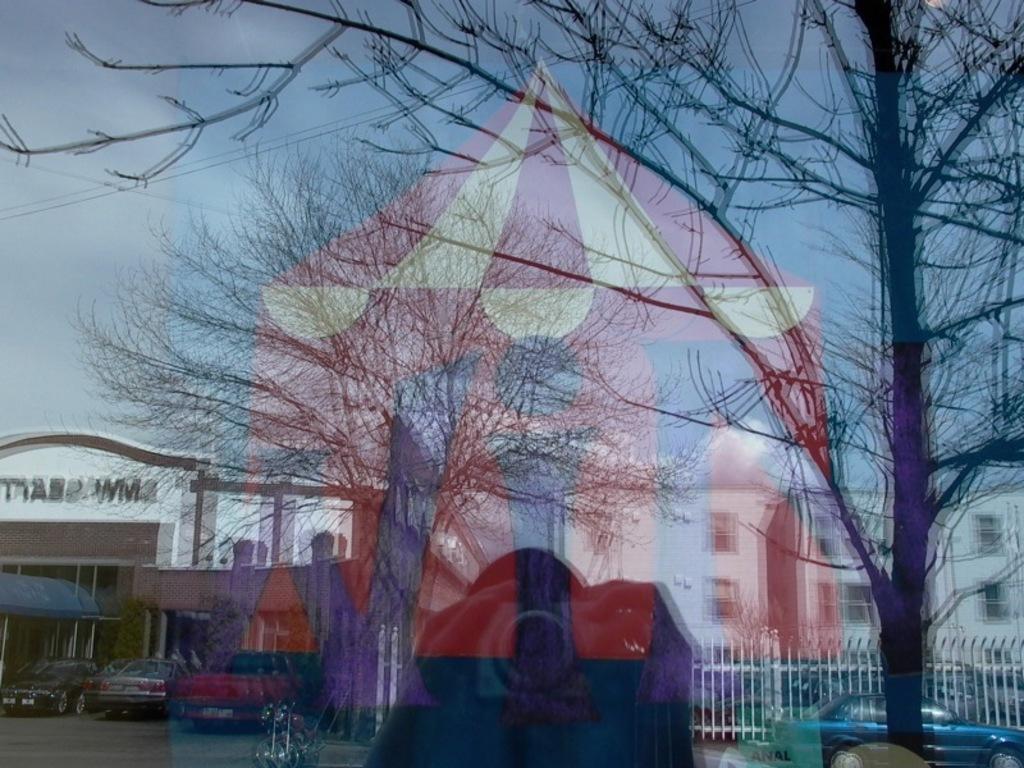Can you describe this image briefly? In this image in the foreground there is a glass door and through the door we could see some poles, and one person is holding a camera and trees railing and sky. 